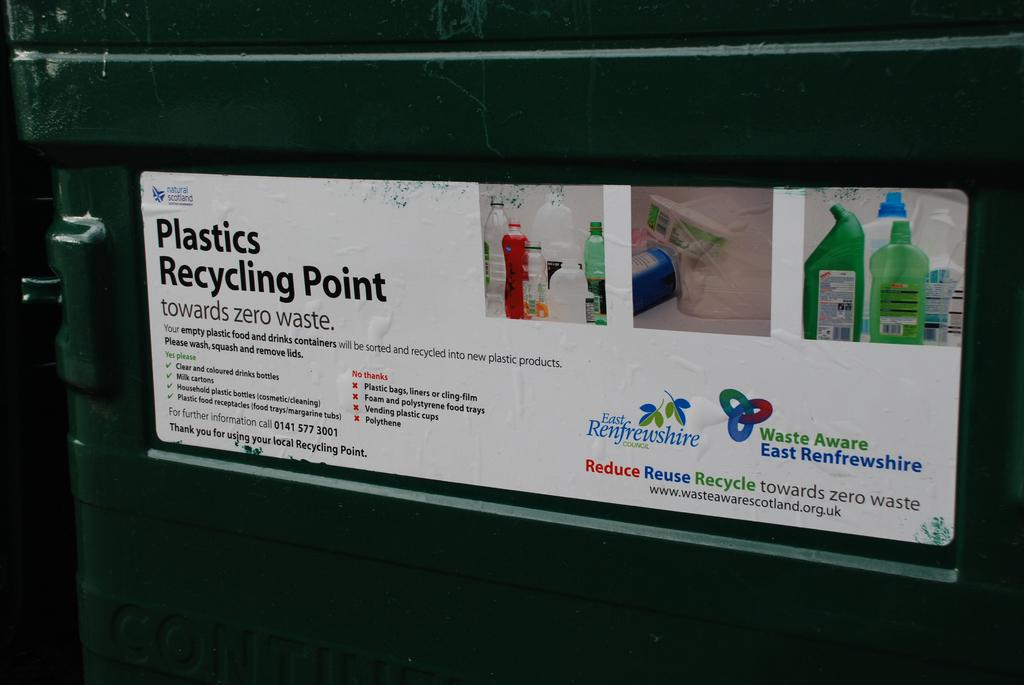<image>
Summarize the visual content of the image. The recycling point explains what can be recycled in it. 